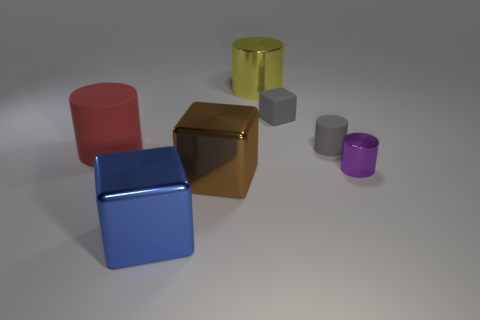The cylinder that is behind the large red cylinder and on the left side of the small block is what color?
Provide a short and direct response. Yellow. What number of other objects are there of the same shape as the tiny purple object?
Offer a terse response. 3. Are there fewer metallic objects behind the blue object than big red rubber things that are on the right side of the big rubber cylinder?
Keep it short and to the point. No. Are the large red object and the cylinder behind the gray matte block made of the same material?
Offer a terse response. No. Is there any other thing that is made of the same material as the small gray block?
Make the answer very short. Yes. Is the number of green metal balls greater than the number of gray cylinders?
Make the answer very short. No. The big object that is behind the rubber cylinder on the left side of the big shiny cylinder on the left side of the tiny cube is what shape?
Provide a succinct answer. Cylinder. Are the small purple object that is right of the red cylinder and the big brown block that is left of the large yellow cylinder made of the same material?
Offer a very short reply. Yes. There is a small thing that is the same material as the yellow cylinder; what is its shape?
Ensure brevity in your answer.  Cylinder. Are there any other things of the same color as the tiny rubber cylinder?
Your answer should be very brief. Yes. 